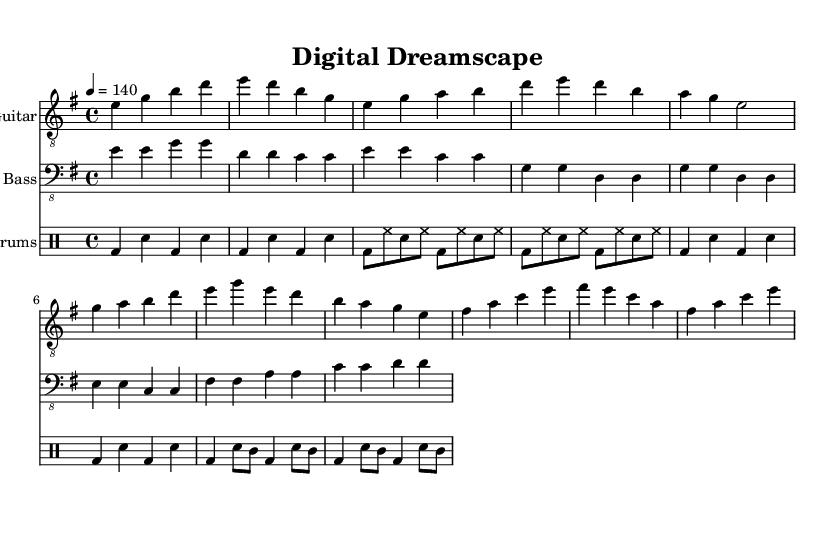What is the key signature of this music? The key signature is E minor, which has one sharp (F#). It can be identified at the beginning of the staff, where the key signature is indicated.
Answer: E minor What is the time signature of this music? The time signature is 4/4, which indicates four beats per measure. It is shown directly at the beginning of the music.
Answer: 4/4 What is the tempo of this piece? The tempo marking indicates a speed of 140 beats per minute (quarter note). This is found in the tempo indication at the start of the score.
Answer: 140 How many measures are in the intro? The intro consists of two measures, as indicated by the grouping of notes and rests at the start of the sheet music for the electric guitar and drums.
Answer: 2 What is the first note played by the electric guitar? The first note played by the electric guitar is E. This can be determined by looking at the first note on the staff.
Answer: E What is the pattern used in the chorus? The chorus uses a recurring pattern of notes that consists of G, A, B, D, and a descending sequence back to E, G, E, D, concluding with B, A, G, E. This pattern can be traced by analyzing the notes in the chorus section of the electric guitar part.
Answer: G, A, B, D, E, G, E, D What type of rhythm does the drums use in the verse? The drums use a combination of bass drum and snare drum with hi-hat patterns that alternate, creating a driving rhythm typical of rock music. This can be analyzed by counting the rhythmic notes in the drum part for the verse.
Answer: Bass-Snare-Hihat 